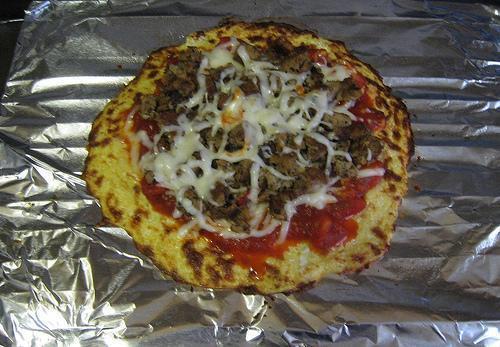How many pizzas are there?
Give a very brief answer. 1. 